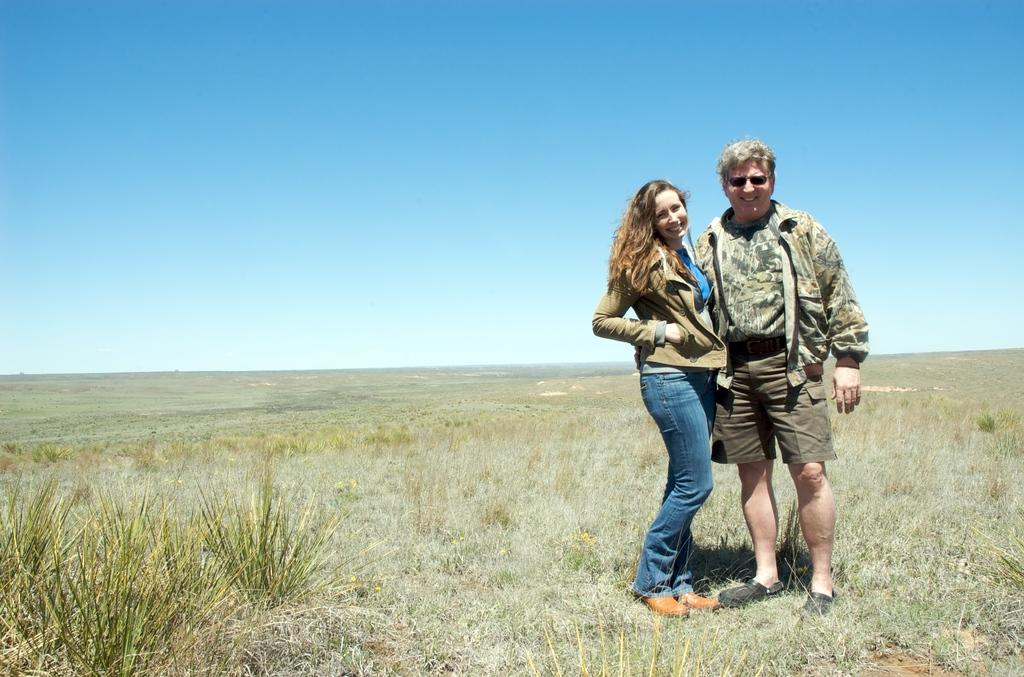Who or what can be seen in the image? There are people in the image. What is the surface that the people are standing on? The ground is visible in the image. What type of vegetation is present in the image? There is grass and plants in the image. What can be seen above the people and vegetation? The sky is visible in the image. How far away is the creator of the image from the scene? There is no information about the creator of the image or their distance from the scene, as we are only looking at the image itself. 